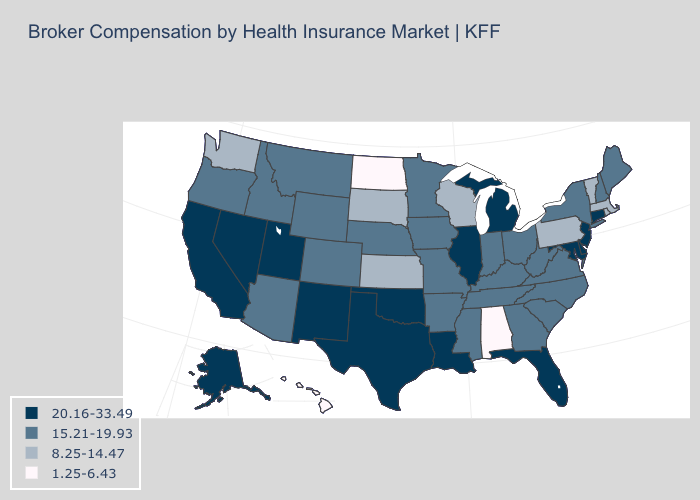Name the states that have a value in the range 8.25-14.47?
Short answer required. Kansas, Massachusetts, Pennsylvania, Rhode Island, South Dakota, Vermont, Washington, Wisconsin. What is the value of Georgia?
Be succinct. 15.21-19.93. Name the states that have a value in the range 20.16-33.49?
Keep it brief. Alaska, California, Connecticut, Delaware, Florida, Illinois, Louisiana, Maryland, Michigan, Nevada, New Jersey, New Mexico, Oklahoma, Texas, Utah. What is the value of Oregon?
Quick response, please. 15.21-19.93. What is the highest value in the Northeast ?
Short answer required. 20.16-33.49. Does Oklahoma have the highest value in the South?
Write a very short answer. Yes. What is the value of New Hampshire?
Answer briefly. 15.21-19.93. Name the states that have a value in the range 8.25-14.47?
Concise answer only. Kansas, Massachusetts, Pennsylvania, Rhode Island, South Dakota, Vermont, Washington, Wisconsin. Does Massachusetts have a higher value than Kansas?
Concise answer only. No. What is the value of New Jersey?
Give a very brief answer. 20.16-33.49. Name the states that have a value in the range 8.25-14.47?
Answer briefly. Kansas, Massachusetts, Pennsylvania, Rhode Island, South Dakota, Vermont, Washington, Wisconsin. Does the map have missing data?
Give a very brief answer. No. Does Missouri have the highest value in the USA?
Give a very brief answer. No. What is the lowest value in the West?
Answer briefly. 1.25-6.43. What is the value of Tennessee?
Keep it brief. 15.21-19.93. 